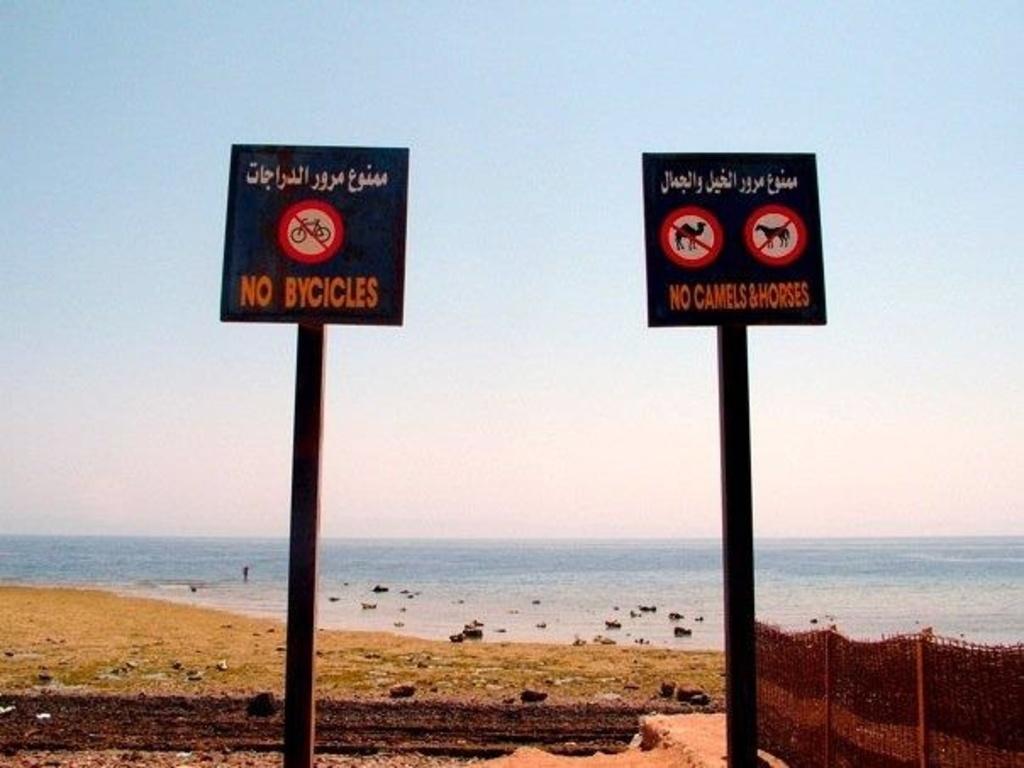What animals besides camels are forbidden on the beach?
Ensure brevity in your answer.  Horses. What animals are not allowed here?
Your response must be concise. Camels & horses. 